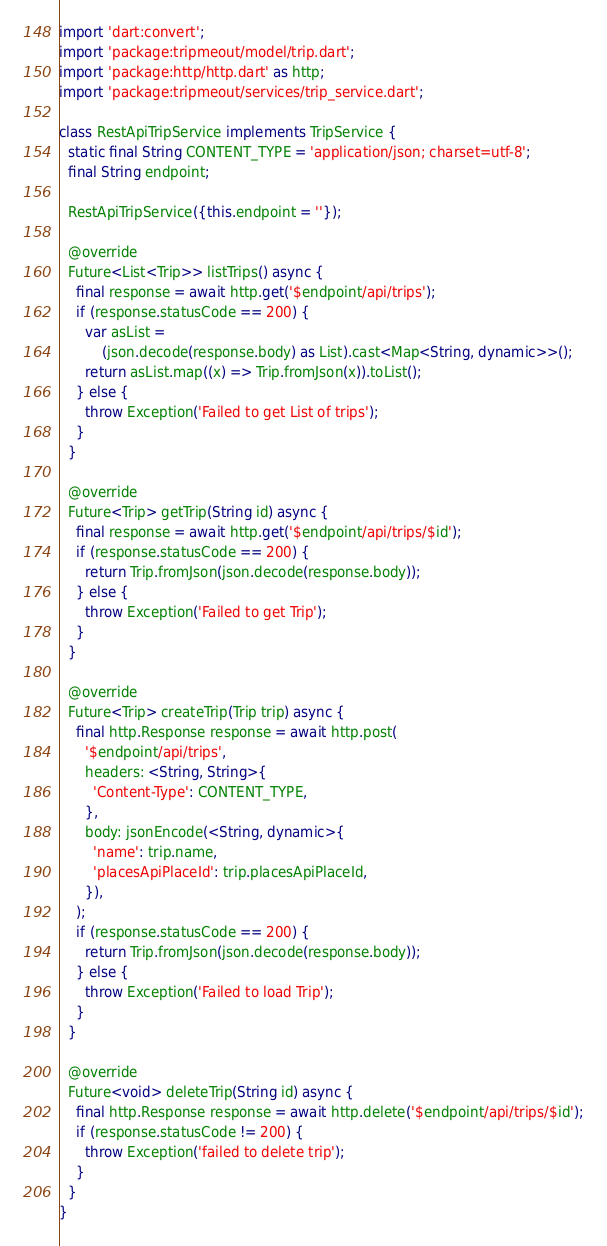<code> <loc_0><loc_0><loc_500><loc_500><_Dart_>import 'dart:convert';
import 'package:tripmeout/model/trip.dart';
import 'package:http/http.dart' as http;
import 'package:tripmeout/services/trip_service.dart';

class RestApiTripService implements TripService {
  static final String CONTENT_TYPE = 'application/json; charset=utf-8';
  final String endpoint;

  RestApiTripService({this.endpoint = ''});

  @override
  Future<List<Trip>> listTrips() async {
    final response = await http.get('$endpoint/api/trips');
    if (response.statusCode == 200) {
      var asList =
          (json.decode(response.body) as List).cast<Map<String, dynamic>>();
      return asList.map((x) => Trip.fromJson(x)).toList();
    } else {
      throw Exception('Failed to get List of trips');
    }
  }

  @override
  Future<Trip> getTrip(String id) async {
    final response = await http.get('$endpoint/api/trips/$id');
    if (response.statusCode == 200) {
      return Trip.fromJson(json.decode(response.body));
    } else {
      throw Exception('Failed to get Trip');
    }
  }

  @override
  Future<Trip> createTrip(Trip trip) async {
    final http.Response response = await http.post(
      '$endpoint/api/trips',
      headers: <String, String>{
        'Content-Type': CONTENT_TYPE,
      },
      body: jsonEncode(<String, dynamic>{
        'name': trip.name,
        'placesApiPlaceId': trip.placesApiPlaceId,
      }),
    );
    if (response.statusCode == 200) {
      return Trip.fromJson(json.decode(response.body));
    } else {
      throw Exception('Failed to load Trip');
    }
  }

  @override
  Future<void> deleteTrip(String id) async {
    final http.Response response = await http.delete('$endpoint/api/trips/$id');
    if (response.statusCode != 200) {
      throw Exception('failed to delete trip');
    }
  }
}
</code> 